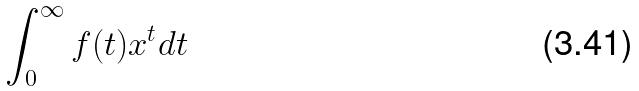<formula> <loc_0><loc_0><loc_500><loc_500>\int _ { 0 } ^ { \infty } f ( t ) x ^ { t } d t</formula> 